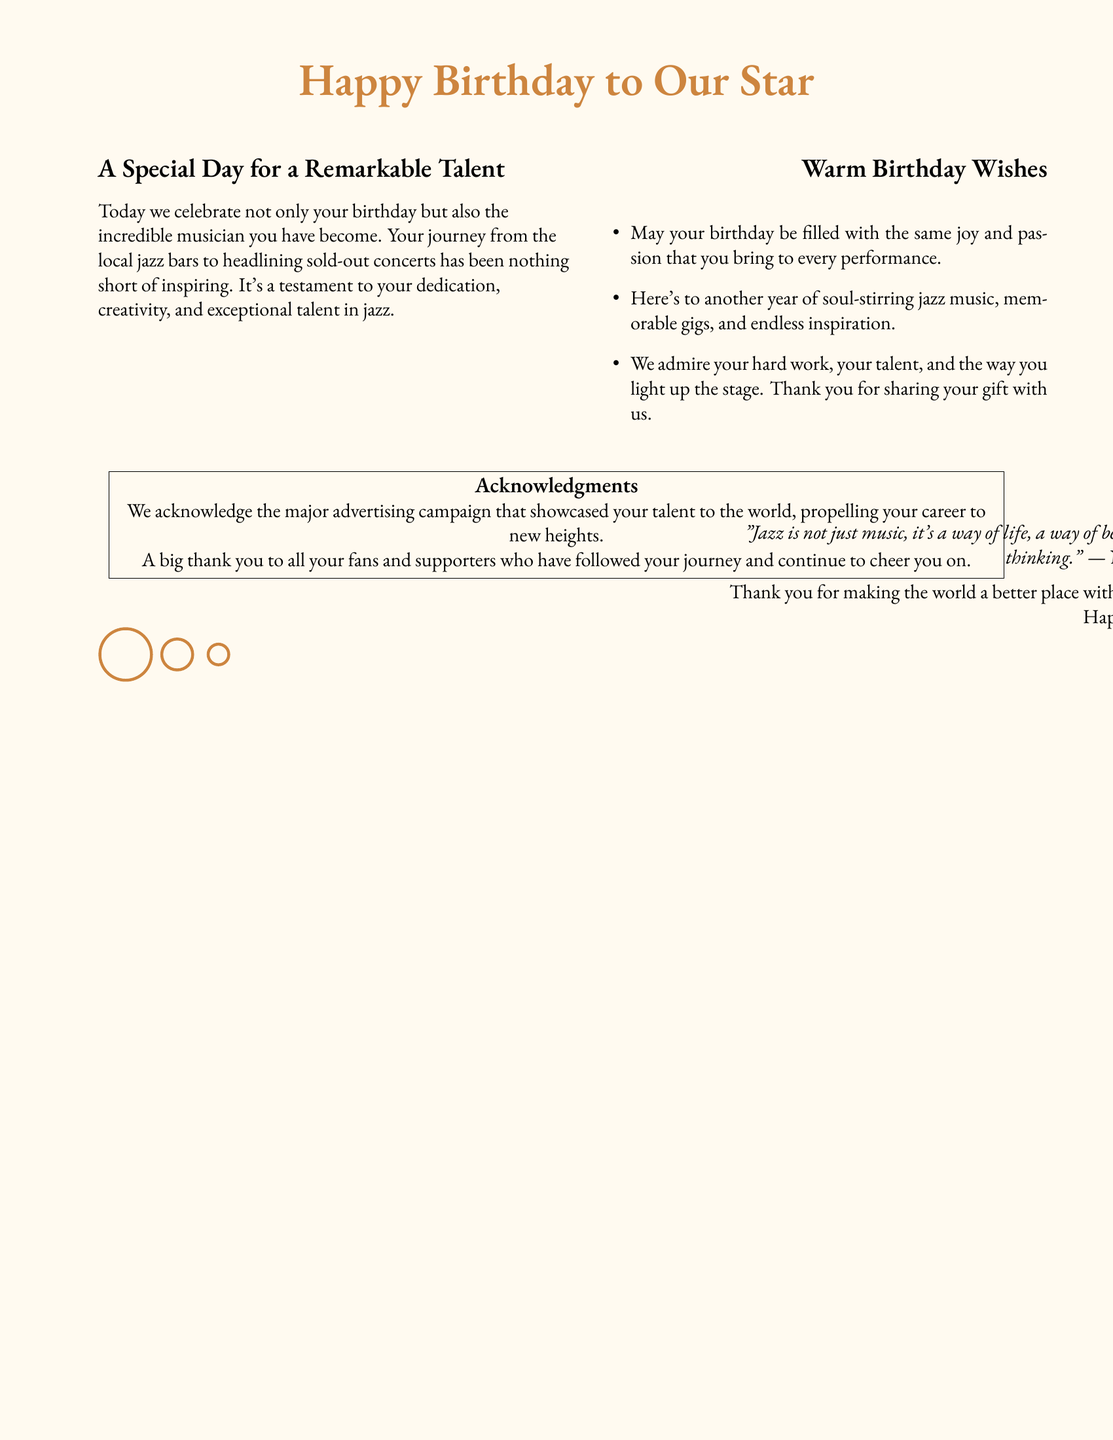What is the title of the card? The title is prominently featured at the top of the card and reads "Happy Birthday to Our Star."
Answer: Happy Birthday to Our Star Who is the card celebrating? The card acknowledges the birthday and talent of a remarkable musician, who is described as a star.
Answer: A remarkable musician What is one of the warm birthday wishes mentioned? The document contains a list of birthday wishes, one being that the birthday is filled with joy and passion.
Answer: Joy and passion What color is used for the background of the card? The document specifies a background color defined as "jazzbg," which is a light, soft hue.
Answer: Light brown What is acknowledged in the card's acknowledgments section? The acknowledgments section mentions the major advertising campaign that showcased the musician's talent.
Answer: Major advertising campaign Who is quoted on the card? The card features a quote attributed to Nina Simone.
Answer: Nina Simone What is expressed in the wishes for the future? The wishes convey hopes for another year of soul-stirring jazz music and memorable gigs.
Answer: Soul-stirring jazz music How are the birthday wishes visually presented? The birthday wishes are organized in a list format with bullet points for clarity.
Answer: List format What sentiment concludes the card? The sentiment expressed in the closing thanks the musician for making the world better with music.
Answer: Thank you for making the world better with your music 